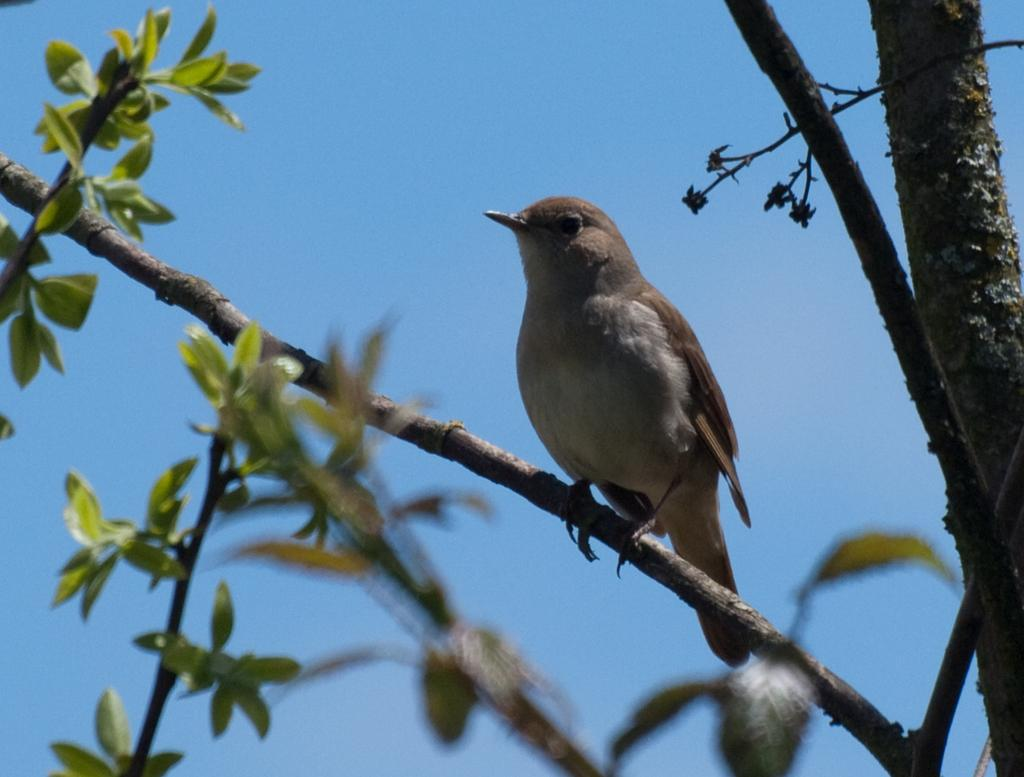What type of animal is in the image? There is a bird in the image. Can you describe the bird's appearance? The bird is cream and brown in color. Where is the bird located in the image? The bird is on a tree. What is the color of the tree? The tree is brown and green in color. What can be seen in the background of the image? The sky is visible in the background of the image. How many apples are the kittens eating in the image? There are no apples or kittens present in the image; it features a bird on a tree. 